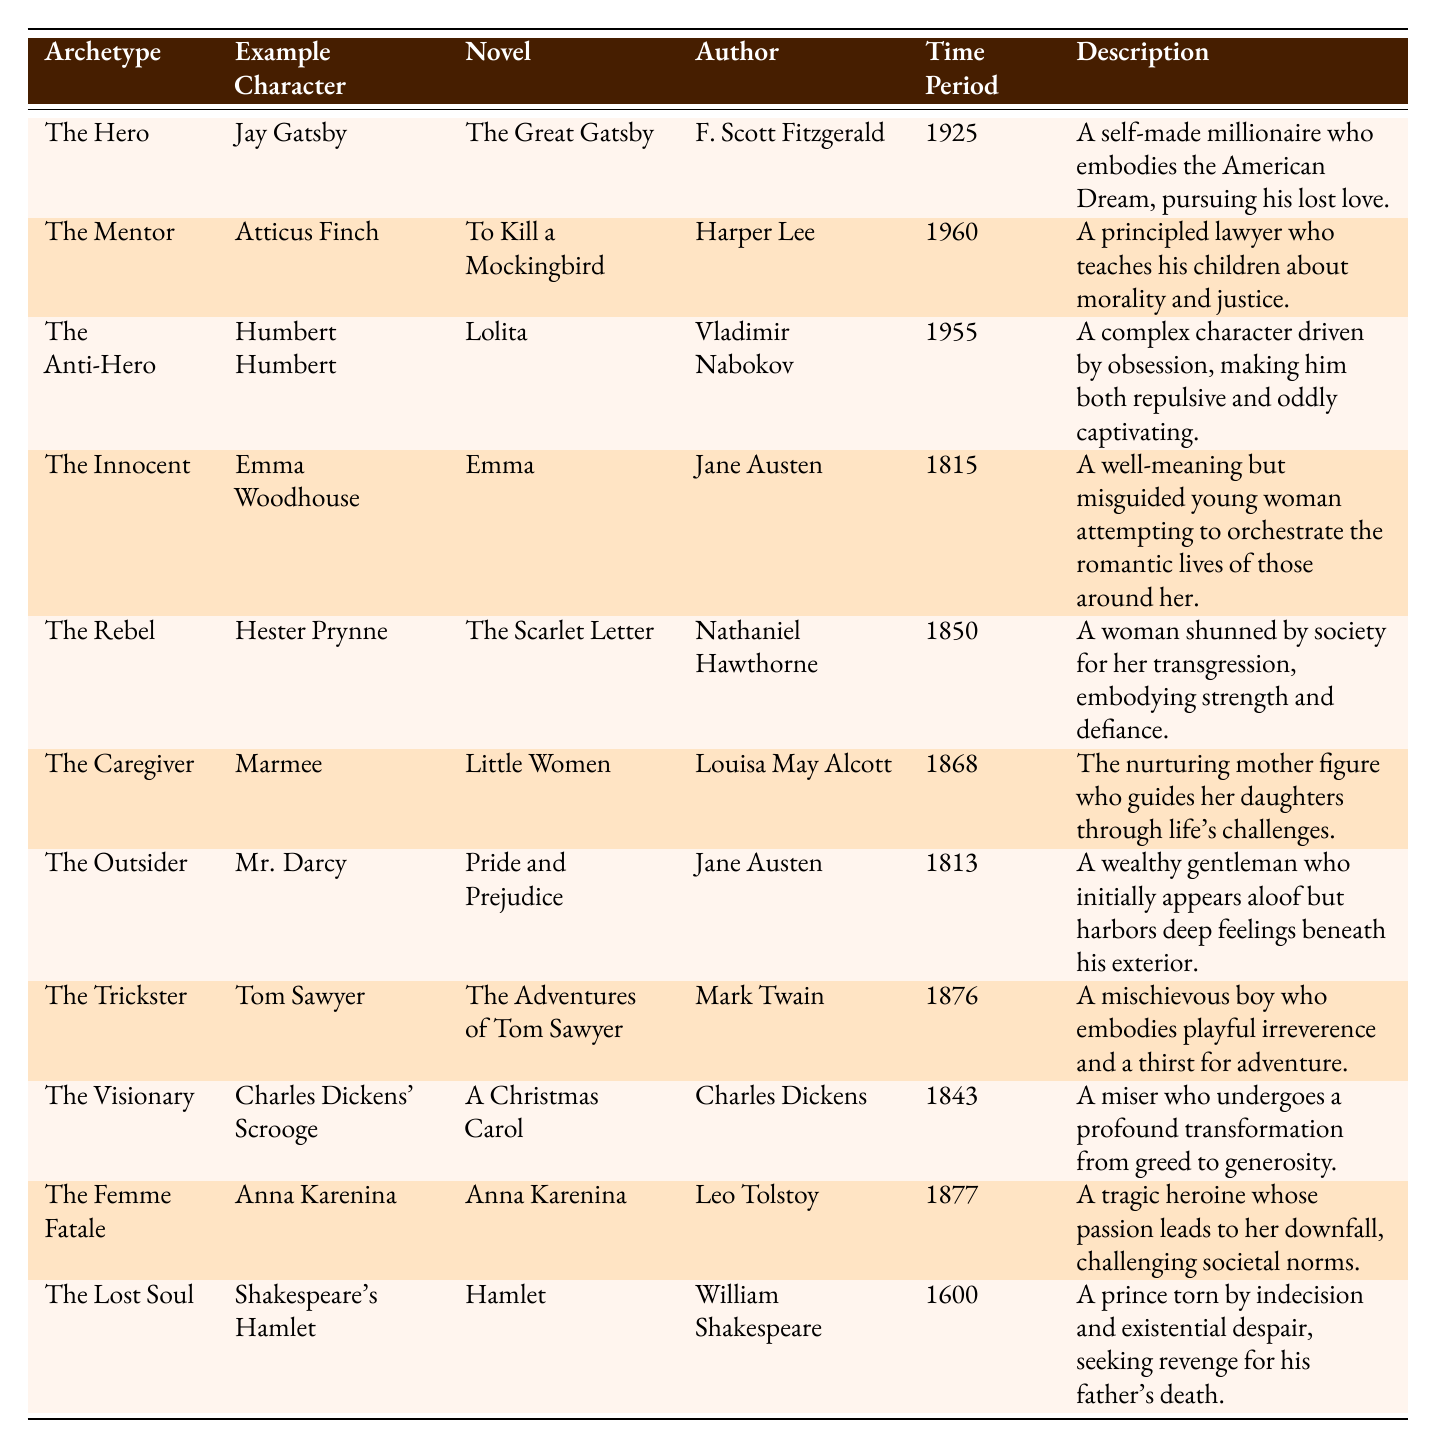What archetype is associated with Jay Gatsby? By looking at the table, the row containing Jay Gatsby indicates that he is associated with "The Hero" archetype.
Answer: The Hero Which novel features Atticus Finch? The table shows that Atticus Finch appears in "To Kill a Mockingbird."
Answer: To Kill a Mockingbird Who is the author of "Lolita"? The table specifies that "Lolita" was written by Vladimir Nabokov.
Answer: Vladimir Nabokov How many archetypes are listed in the table? The table shows a total of 11 archetypes listed, counting each row.
Answer: 11 What is the time period of "Emma"? The entry for "Emma" indicates that it was published in 1815.
Answer: 1815 Is "The Scarlet Letter" associated with the archetype of The Innocent? The table indicates that "The Scarlet Letter" is associated with "The Rebel," not "The Innocent.”
Answer: No Who is the example character for "The Caregiver"? The table shows that Marmee is the example character for "The Caregiver."
Answer: Marmee Which archetype is represented by a character that embodies strength and defiance? The table states that Hester Prynne from "The Scarlet Letter" embodies strength and defiance, associated with "The Rebel."
Answer: The Rebel How many characters are listed as anti-heroes? The table features only one character classified as an anti-hero: Humbert Humbert from "Lolita."
Answer: 1 What time period represents the novel featuring both the character Emma Woodhouse and the author Jane Austen? The row for "Emma" shows it is from 1815, which is the same year as Jane Austen's publication.
Answer: 1815 Which character's description reflects a transformation from greed to generosity? The description in the table for Charles Dickens' Scrooge indicates a transformation from greed to generosity.
Answer: Charles Dickens' Scrooge List all archetypes represented by characters written before the 20th century. The table contains "The Innocent," "The Rebel," "The Caregiver," "The Outsider," "The Trickster," and "The Visionary," all written before 1900.
Answer: The Innocent, The Rebel, The Caregiver, The Outsider, The Trickster, The Visionary Which character from the table is an example of a femme fatale? The table specifies that Anna Karenina is an example of a femme fatale.
Answer: Anna Karenina What similarities can you identify between "Hamlet" and "Lolita"? Both characters, Hamlet and Humbert Humbert, are complex figures with deep internal struggles, but they represent different archetypes (The Lost Soul and The Anti-Hero, respectively).
Answer: Complex internal struggles What percentage of characters in the table are classified as heroes or heroines? There are 2 heroes (Jay Gatsby and Humbert Humbert not strictly a hero), and 11 archetypes, giving a percentage of (2/11)*100 ≈ 18.18%.
Answer: Approximately 18.18% What titles were associated with Jane Austen in this table? The table lists "Emma" and "Pride and Prejudice," both of which feature characters created by Jane Austen.
Answer: Emma and Pride and Prejudice 